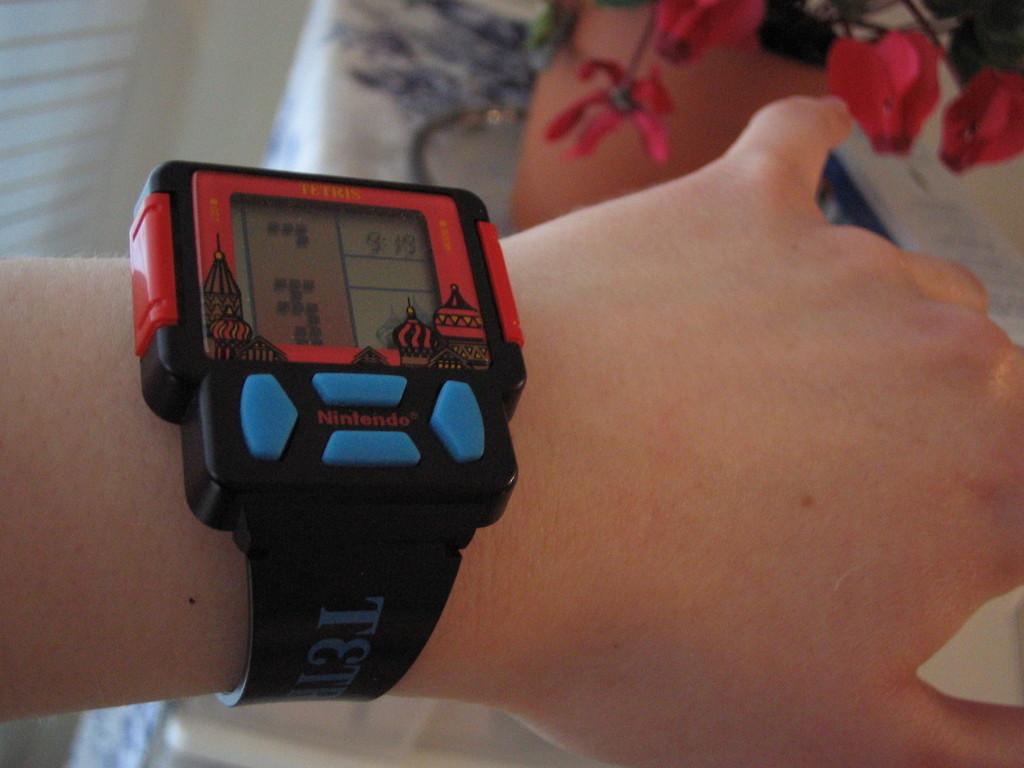What brand of watch is this?
Provide a short and direct response. Nintendo. What the title of the game on the watch?
Ensure brevity in your answer.  Tetris. 